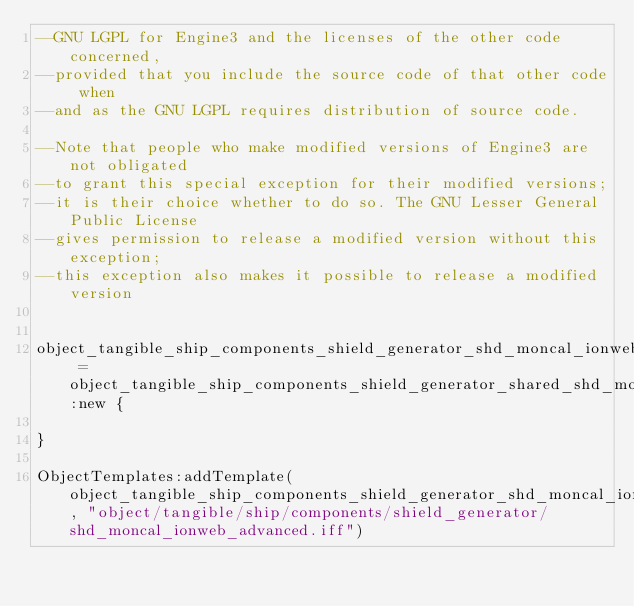<code> <loc_0><loc_0><loc_500><loc_500><_Lua_>--GNU LGPL for Engine3 and the licenses of the other code concerned, 
--provided that you include the source code of that other code when 
--and as the GNU LGPL requires distribution of source code.

--Note that people who make modified versions of Engine3 are not obligated 
--to grant this special exception for their modified versions; 
--it is their choice whether to do so. The GNU Lesser General Public License 
--gives permission to release a modified version without this exception; 
--this exception also makes it possible to release a modified version 


object_tangible_ship_components_shield_generator_shd_moncal_ionweb_advanced = object_tangible_ship_components_shield_generator_shared_shd_moncal_ionweb_advanced:new {

}

ObjectTemplates:addTemplate(object_tangible_ship_components_shield_generator_shd_moncal_ionweb_advanced, "object/tangible/ship/components/shield_generator/shd_moncal_ionweb_advanced.iff")
</code> 